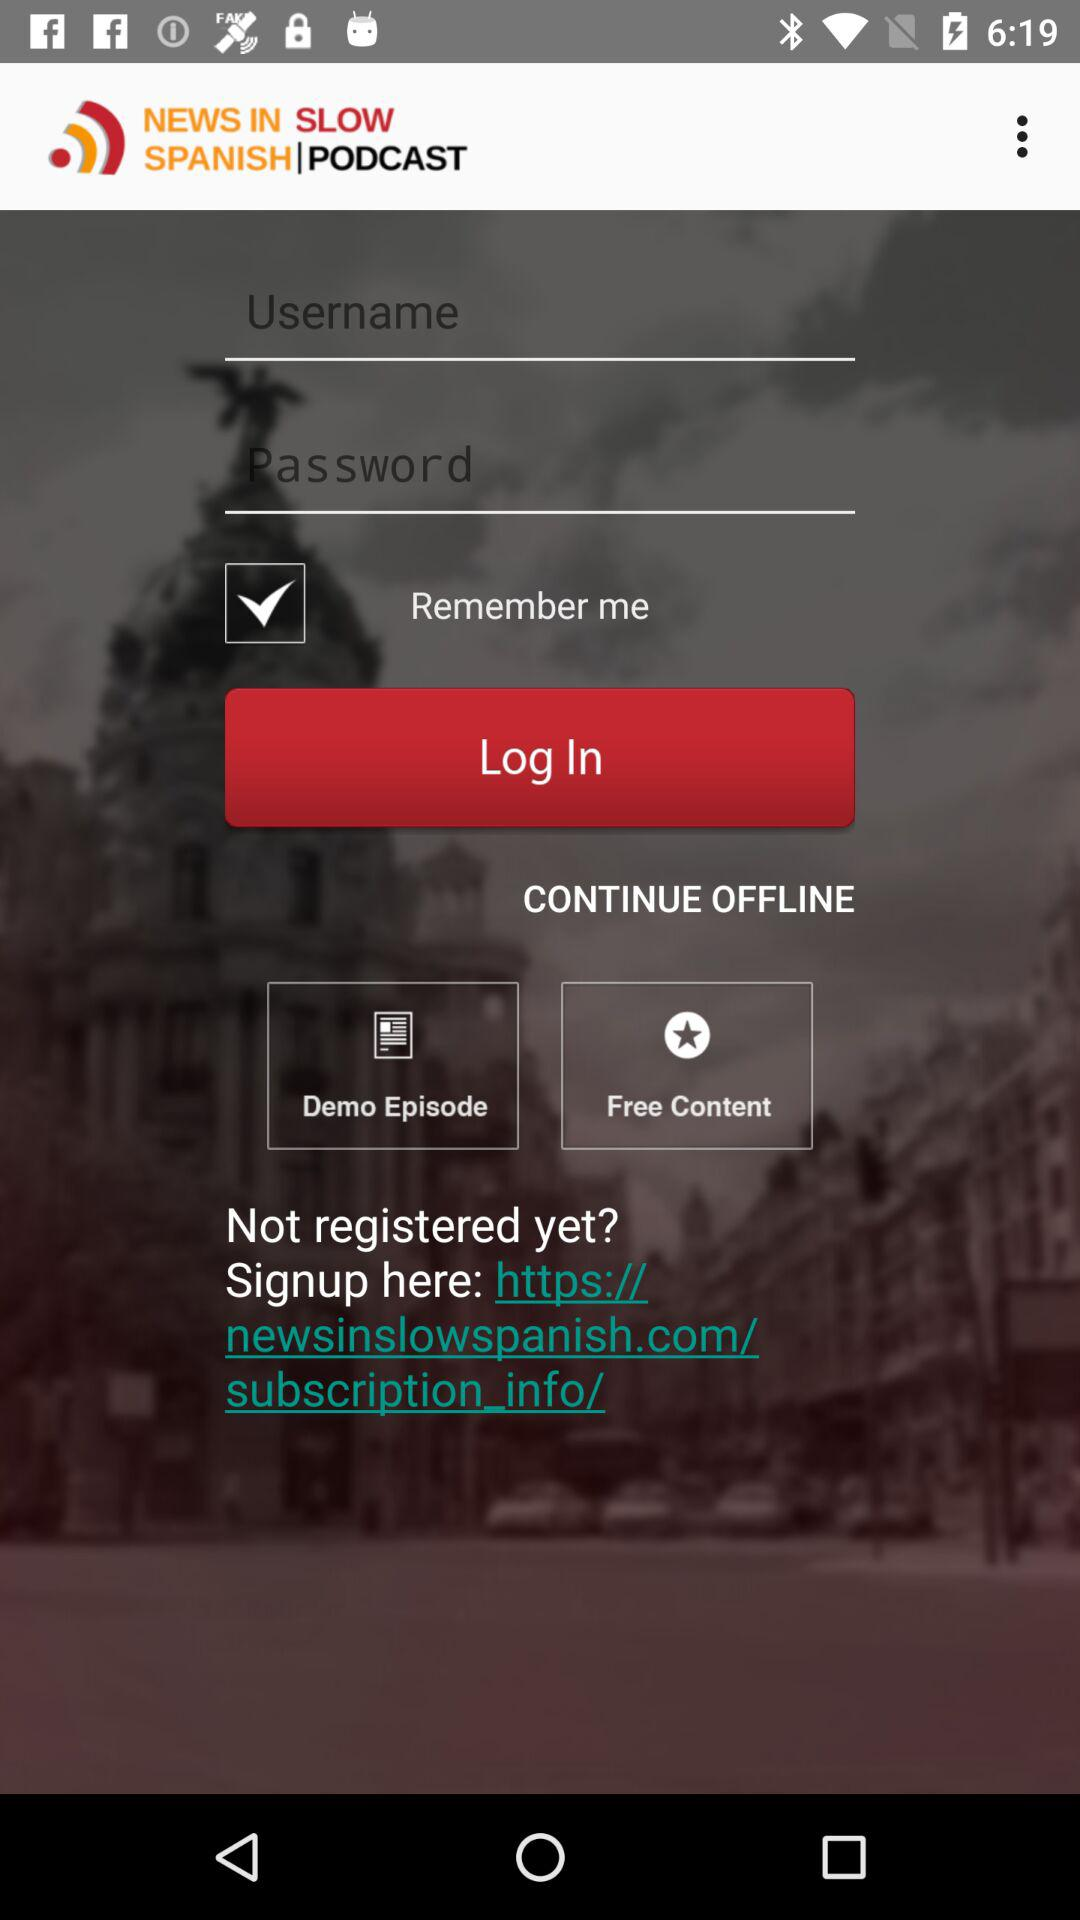What is the name of the application? The name of the application is "NEWS IN SLOW SPANISH". 